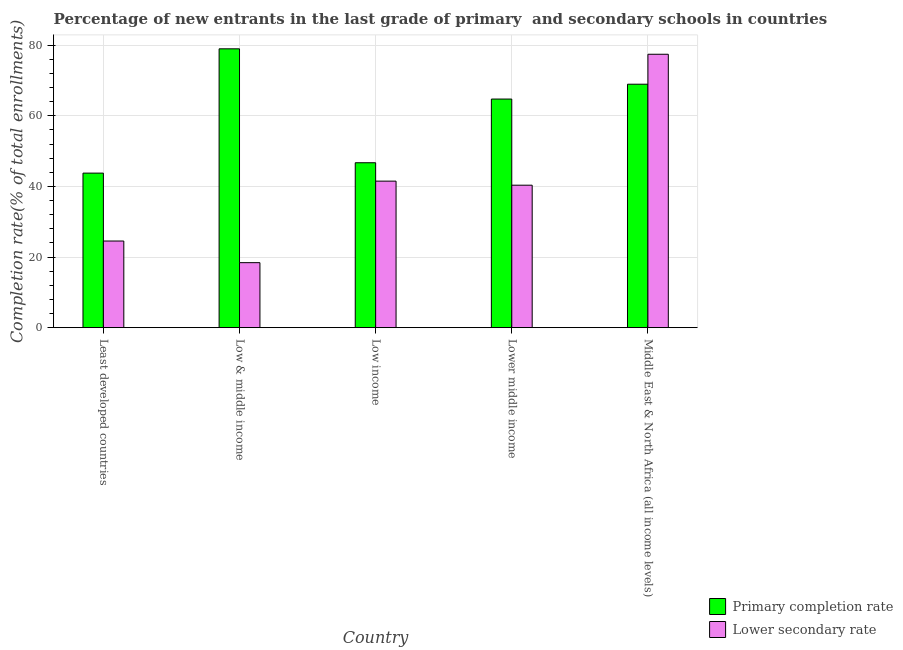How many different coloured bars are there?
Ensure brevity in your answer.  2. Are the number of bars per tick equal to the number of legend labels?
Your answer should be very brief. Yes. How many bars are there on the 2nd tick from the left?
Ensure brevity in your answer.  2. How many bars are there on the 5th tick from the right?
Your response must be concise. 2. In how many cases, is the number of bars for a given country not equal to the number of legend labels?
Give a very brief answer. 0. What is the completion rate in secondary schools in Least developed countries?
Your answer should be compact. 24.53. Across all countries, what is the maximum completion rate in secondary schools?
Ensure brevity in your answer.  77.42. Across all countries, what is the minimum completion rate in primary schools?
Your answer should be compact. 43.76. In which country was the completion rate in secondary schools maximum?
Keep it short and to the point. Middle East & North Africa (all income levels). What is the total completion rate in primary schools in the graph?
Your response must be concise. 303.1. What is the difference between the completion rate in secondary schools in Low income and that in Lower middle income?
Provide a succinct answer. 1.15. What is the difference between the completion rate in secondary schools in Middle East & North Africa (all income levels) and the completion rate in primary schools in Least developed countries?
Your response must be concise. 33.66. What is the average completion rate in primary schools per country?
Offer a very short reply. 60.62. What is the difference between the completion rate in primary schools and completion rate in secondary schools in Lower middle income?
Your response must be concise. 24.39. What is the ratio of the completion rate in primary schools in Lower middle income to that in Middle East & North Africa (all income levels)?
Provide a succinct answer. 0.94. Is the completion rate in secondary schools in Least developed countries less than that in Low income?
Keep it short and to the point. Yes. What is the difference between the highest and the second highest completion rate in secondary schools?
Give a very brief answer. 35.93. What is the difference between the highest and the lowest completion rate in secondary schools?
Your answer should be very brief. 59.02. Is the sum of the completion rate in secondary schools in Low & middle income and Lower middle income greater than the maximum completion rate in primary schools across all countries?
Keep it short and to the point. No. What does the 1st bar from the left in Lower middle income represents?
Provide a short and direct response. Primary completion rate. What does the 1st bar from the right in Least developed countries represents?
Make the answer very short. Lower secondary rate. How many bars are there?
Keep it short and to the point. 10. How many countries are there in the graph?
Ensure brevity in your answer.  5. Are the values on the major ticks of Y-axis written in scientific E-notation?
Offer a very short reply. No. Where does the legend appear in the graph?
Provide a short and direct response. Bottom right. How many legend labels are there?
Make the answer very short. 2. What is the title of the graph?
Your answer should be very brief. Percentage of new entrants in the last grade of primary  and secondary schools in countries. What is the label or title of the X-axis?
Give a very brief answer. Country. What is the label or title of the Y-axis?
Your answer should be compact. Completion rate(% of total enrollments). What is the Completion rate(% of total enrollments) of Primary completion rate in Least developed countries?
Provide a short and direct response. 43.76. What is the Completion rate(% of total enrollments) in Lower secondary rate in Least developed countries?
Offer a very short reply. 24.53. What is the Completion rate(% of total enrollments) in Primary completion rate in Low & middle income?
Offer a terse response. 78.96. What is the Completion rate(% of total enrollments) of Lower secondary rate in Low & middle income?
Your answer should be very brief. 18.4. What is the Completion rate(% of total enrollments) in Primary completion rate in Low income?
Your answer should be very brief. 46.7. What is the Completion rate(% of total enrollments) of Lower secondary rate in Low income?
Make the answer very short. 41.49. What is the Completion rate(% of total enrollments) of Primary completion rate in Lower middle income?
Offer a terse response. 64.73. What is the Completion rate(% of total enrollments) in Lower secondary rate in Lower middle income?
Provide a short and direct response. 40.34. What is the Completion rate(% of total enrollments) in Primary completion rate in Middle East & North Africa (all income levels)?
Your response must be concise. 68.94. What is the Completion rate(% of total enrollments) in Lower secondary rate in Middle East & North Africa (all income levels)?
Your answer should be compact. 77.42. Across all countries, what is the maximum Completion rate(% of total enrollments) in Primary completion rate?
Give a very brief answer. 78.96. Across all countries, what is the maximum Completion rate(% of total enrollments) of Lower secondary rate?
Your answer should be compact. 77.42. Across all countries, what is the minimum Completion rate(% of total enrollments) in Primary completion rate?
Offer a terse response. 43.76. Across all countries, what is the minimum Completion rate(% of total enrollments) in Lower secondary rate?
Keep it short and to the point. 18.4. What is the total Completion rate(% of total enrollments) in Primary completion rate in the graph?
Your response must be concise. 303.1. What is the total Completion rate(% of total enrollments) in Lower secondary rate in the graph?
Provide a succinct answer. 202.19. What is the difference between the Completion rate(% of total enrollments) of Primary completion rate in Least developed countries and that in Low & middle income?
Keep it short and to the point. -35.2. What is the difference between the Completion rate(% of total enrollments) in Lower secondary rate in Least developed countries and that in Low & middle income?
Keep it short and to the point. 6.13. What is the difference between the Completion rate(% of total enrollments) in Primary completion rate in Least developed countries and that in Low income?
Your answer should be compact. -2.94. What is the difference between the Completion rate(% of total enrollments) in Lower secondary rate in Least developed countries and that in Low income?
Make the answer very short. -16.96. What is the difference between the Completion rate(% of total enrollments) in Primary completion rate in Least developed countries and that in Lower middle income?
Give a very brief answer. -20.97. What is the difference between the Completion rate(% of total enrollments) in Lower secondary rate in Least developed countries and that in Lower middle income?
Make the answer very short. -15.81. What is the difference between the Completion rate(% of total enrollments) of Primary completion rate in Least developed countries and that in Middle East & North Africa (all income levels)?
Your answer should be compact. -25.18. What is the difference between the Completion rate(% of total enrollments) of Lower secondary rate in Least developed countries and that in Middle East & North Africa (all income levels)?
Provide a succinct answer. -52.89. What is the difference between the Completion rate(% of total enrollments) of Primary completion rate in Low & middle income and that in Low income?
Offer a terse response. 32.26. What is the difference between the Completion rate(% of total enrollments) of Lower secondary rate in Low & middle income and that in Low income?
Keep it short and to the point. -23.09. What is the difference between the Completion rate(% of total enrollments) in Primary completion rate in Low & middle income and that in Lower middle income?
Offer a very short reply. 14.23. What is the difference between the Completion rate(% of total enrollments) of Lower secondary rate in Low & middle income and that in Lower middle income?
Offer a terse response. -21.94. What is the difference between the Completion rate(% of total enrollments) in Primary completion rate in Low & middle income and that in Middle East & North Africa (all income levels)?
Make the answer very short. 10.02. What is the difference between the Completion rate(% of total enrollments) in Lower secondary rate in Low & middle income and that in Middle East & North Africa (all income levels)?
Provide a short and direct response. -59.02. What is the difference between the Completion rate(% of total enrollments) of Primary completion rate in Low income and that in Lower middle income?
Your answer should be very brief. -18.04. What is the difference between the Completion rate(% of total enrollments) in Lower secondary rate in Low income and that in Lower middle income?
Your answer should be compact. 1.15. What is the difference between the Completion rate(% of total enrollments) in Primary completion rate in Low income and that in Middle East & North Africa (all income levels)?
Provide a short and direct response. -22.24. What is the difference between the Completion rate(% of total enrollments) in Lower secondary rate in Low income and that in Middle East & North Africa (all income levels)?
Make the answer very short. -35.93. What is the difference between the Completion rate(% of total enrollments) of Primary completion rate in Lower middle income and that in Middle East & North Africa (all income levels)?
Offer a terse response. -4.2. What is the difference between the Completion rate(% of total enrollments) in Lower secondary rate in Lower middle income and that in Middle East & North Africa (all income levels)?
Keep it short and to the point. -37.08. What is the difference between the Completion rate(% of total enrollments) of Primary completion rate in Least developed countries and the Completion rate(% of total enrollments) of Lower secondary rate in Low & middle income?
Your answer should be compact. 25.36. What is the difference between the Completion rate(% of total enrollments) in Primary completion rate in Least developed countries and the Completion rate(% of total enrollments) in Lower secondary rate in Low income?
Provide a succinct answer. 2.27. What is the difference between the Completion rate(% of total enrollments) of Primary completion rate in Least developed countries and the Completion rate(% of total enrollments) of Lower secondary rate in Lower middle income?
Make the answer very short. 3.42. What is the difference between the Completion rate(% of total enrollments) in Primary completion rate in Least developed countries and the Completion rate(% of total enrollments) in Lower secondary rate in Middle East & North Africa (all income levels)?
Keep it short and to the point. -33.66. What is the difference between the Completion rate(% of total enrollments) in Primary completion rate in Low & middle income and the Completion rate(% of total enrollments) in Lower secondary rate in Low income?
Your response must be concise. 37.47. What is the difference between the Completion rate(% of total enrollments) of Primary completion rate in Low & middle income and the Completion rate(% of total enrollments) of Lower secondary rate in Lower middle income?
Make the answer very short. 38.62. What is the difference between the Completion rate(% of total enrollments) of Primary completion rate in Low & middle income and the Completion rate(% of total enrollments) of Lower secondary rate in Middle East & North Africa (all income levels)?
Your answer should be very brief. 1.54. What is the difference between the Completion rate(% of total enrollments) in Primary completion rate in Low income and the Completion rate(% of total enrollments) in Lower secondary rate in Lower middle income?
Offer a very short reply. 6.36. What is the difference between the Completion rate(% of total enrollments) of Primary completion rate in Low income and the Completion rate(% of total enrollments) of Lower secondary rate in Middle East & North Africa (all income levels)?
Make the answer very short. -30.72. What is the difference between the Completion rate(% of total enrollments) in Primary completion rate in Lower middle income and the Completion rate(% of total enrollments) in Lower secondary rate in Middle East & North Africa (all income levels)?
Provide a succinct answer. -12.68. What is the average Completion rate(% of total enrollments) of Primary completion rate per country?
Your answer should be compact. 60.62. What is the average Completion rate(% of total enrollments) in Lower secondary rate per country?
Make the answer very short. 40.44. What is the difference between the Completion rate(% of total enrollments) in Primary completion rate and Completion rate(% of total enrollments) in Lower secondary rate in Least developed countries?
Keep it short and to the point. 19.23. What is the difference between the Completion rate(% of total enrollments) of Primary completion rate and Completion rate(% of total enrollments) of Lower secondary rate in Low & middle income?
Your answer should be compact. 60.56. What is the difference between the Completion rate(% of total enrollments) of Primary completion rate and Completion rate(% of total enrollments) of Lower secondary rate in Low income?
Your response must be concise. 5.21. What is the difference between the Completion rate(% of total enrollments) in Primary completion rate and Completion rate(% of total enrollments) in Lower secondary rate in Lower middle income?
Your answer should be compact. 24.39. What is the difference between the Completion rate(% of total enrollments) in Primary completion rate and Completion rate(% of total enrollments) in Lower secondary rate in Middle East & North Africa (all income levels)?
Provide a short and direct response. -8.48. What is the ratio of the Completion rate(% of total enrollments) in Primary completion rate in Least developed countries to that in Low & middle income?
Provide a short and direct response. 0.55. What is the ratio of the Completion rate(% of total enrollments) in Lower secondary rate in Least developed countries to that in Low & middle income?
Make the answer very short. 1.33. What is the ratio of the Completion rate(% of total enrollments) of Primary completion rate in Least developed countries to that in Low income?
Keep it short and to the point. 0.94. What is the ratio of the Completion rate(% of total enrollments) in Lower secondary rate in Least developed countries to that in Low income?
Make the answer very short. 0.59. What is the ratio of the Completion rate(% of total enrollments) of Primary completion rate in Least developed countries to that in Lower middle income?
Give a very brief answer. 0.68. What is the ratio of the Completion rate(% of total enrollments) in Lower secondary rate in Least developed countries to that in Lower middle income?
Your response must be concise. 0.61. What is the ratio of the Completion rate(% of total enrollments) of Primary completion rate in Least developed countries to that in Middle East & North Africa (all income levels)?
Give a very brief answer. 0.63. What is the ratio of the Completion rate(% of total enrollments) in Lower secondary rate in Least developed countries to that in Middle East & North Africa (all income levels)?
Make the answer very short. 0.32. What is the ratio of the Completion rate(% of total enrollments) in Primary completion rate in Low & middle income to that in Low income?
Ensure brevity in your answer.  1.69. What is the ratio of the Completion rate(% of total enrollments) in Lower secondary rate in Low & middle income to that in Low income?
Make the answer very short. 0.44. What is the ratio of the Completion rate(% of total enrollments) in Primary completion rate in Low & middle income to that in Lower middle income?
Provide a short and direct response. 1.22. What is the ratio of the Completion rate(% of total enrollments) in Lower secondary rate in Low & middle income to that in Lower middle income?
Your answer should be compact. 0.46. What is the ratio of the Completion rate(% of total enrollments) in Primary completion rate in Low & middle income to that in Middle East & North Africa (all income levels)?
Offer a very short reply. 1.15. What is the ratio of the Completion rate(% of total enrollments) in Lower secondary rate in Low & middle income to that in Middle East & North Africa (all income levels)?
Make the answer very short. 0.24. What is the ratio of the Completion rate(% of total enrollments) in Primary completion rate in Low income to that in Lower middle income?
Ensure brevity in your answer.  0.72. What is the ratio of the Completion rate(% of total enrollments) of Lower secondary rate in Low income to that in Lower middle income?
Make the answer very short. 1.03. What is the ratio of the Completion rate(% of total enrollments) of Primary completion rate in Low income to that in Middle East & North Africa (all income levels)?
Your response must be concise. 0.68. What is the ratio of the Completion rate(% of total enrollments) of Lower secondary rate in Low income to that in Middle East & North Africa (all income levels)?
Offer a terse response. 0.54. What is the ratio of the Completion rate(% of total enrollments) of Primary completion rate in Lower middle income to that in Middle East & North Africa (all income levels)?
Make the answer very short. 0.94. What is the ratio of the Completion rate(% of total enrollments) in Lower secondary rate in Lower middle income to that in Middle East & North Africa (all income levels)?
Make the answer very short. 0.52. What is the difference between the highest and the second highest Completion rate(% of total enrollments) of Primary completion rate?
Offer a terse response. 10.02. What is the difference between the highest and the second highest Completion rate(% of total enrollments) of Lower secondary rate?
Give a very brief answer. 35.93. What is the difference between the highest and the lowest Completion rate(% of total enrollments) in Primary completion rate?
Your response must be concise. 35.2. What is the difference between the highest and the lowest Completion rate(% of total enrollments) in Lower secondary rate?
Your answer should be compact. 59.02. 